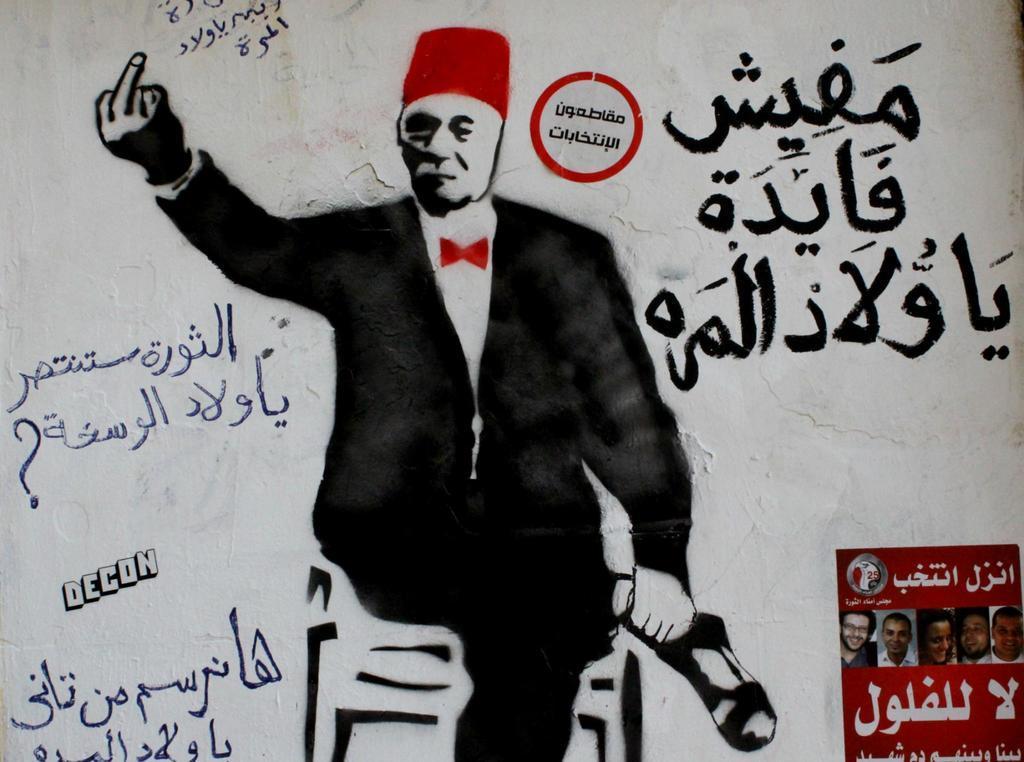In one or two sentences, can you explain what this image depicts? In this image there is a painting of a person on the wall, there are some texts written and two posters on the wall. 